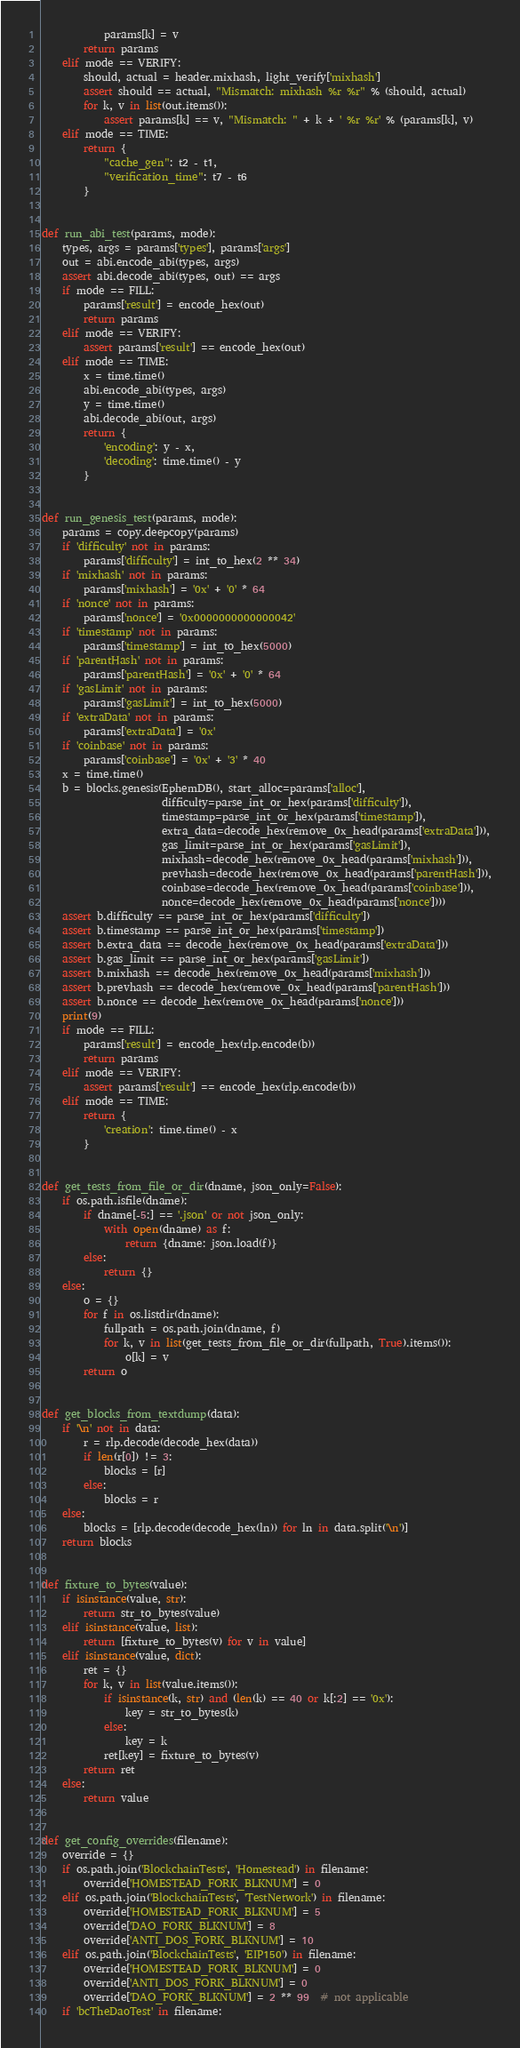Convert code to text. <code><loc_0><loc_0><loc_500><loc_500><_Python_>            params[k] = v
        return params
    elif mode == VERIFY:
        should, actual = header.mixhash, light_verify['mixhash']
        assert should == actual, "Mismatch: mixhash %r %r" % (should, actual)
        for k, v in list(out.items()):
            assert params[k] == v, "Mismatch: " + k + ' %r %r' % (params[k], v)
    elif mode == TIME:
        return {
            "cache_gen": t2 - t1,
            "verification_time": t7 - t6
        }


def run_abi_test(params, mode):
    types, args = params['types'], params['args']
    out = abi.encode_abi(types, args)
    assert abi.decode_abi(types, out) == args
    if mode == FILL:
        params['result'] = encode_hex(out)
        return params
    elif mode == VERIFY:
        assert params['result'] == encode_hex(out)
    elif mode == TIME:
        x = time.time()
        abi.encode_abi(types, args)
        y = time.time()
        abi.decode_abi(out, args)
        return {
            'encoding': y - x,
            'decoding': time.time() - y
        }


def run_genesis_test(params, mode):
    params = copy.deepcopy(params)
    if 'difficulty' not in params:
        params['difficulty'] = int_to_hex(2 ** 34)
    if 'mixhash' not in params:
        params['mixhash'] = '0x' + '0' * 64
    if 'nonce' not in params:
        params['nonce'] = '0x0000000000000042'
    if 'timestamp' not in params:
        params['timestamp'] = int_to_hex(5000)
    if 'parentHash' not in params:
        params['parentHash'] = '0x' + '0' * 64
    if 'gasLimit' not in params:
        params['gasLimit'] = int_to_hex(5000)
    if 'extraData' not in params:
        params['extraData'] = '0x'
    if 'coinbase' not in params:
        params['coinbase'] = '0x' + '3' * 40
    x = time.time()
    b = blocks.genesis(EphemDB(), start_alloc=params['alloc'],
                       difficulty=parse_int_or_hex(params['difficulty']),
                       timestamp=parse_int_or_hex(params['timestamp']),
                       extra_data=decode_hex(remove_0x_head(params['extraData'])),
                       gas_limit=parse_int_or_hex(params['gasLimit']),
                       mixhash=decode_hex(remove_0x_head(params['mixhash'])),
                       prevhash=decode_hex(remove_0x_head(params['parentHash'])),
                       coinbase=decode_hex(remove_0x_head(params['coinbase'])),
                       nonce=decode_hex(remove_0x_head(params['nonce'])))
    assert b.difficulty == parse_int_or_hex(params['difficulty'])
    assert b.timestamp == parse_int_or_hex(params['timestamp'])
    assert b.extra_data == decode_hex(remove_0x_head(params['extraData']))
    assert b.gas_limit == parse_int_or_hex(params['gasLimit'])
    assert b.mixhash == decode_hex(remove_0x_head(params['mixhash']))
    assert b.prevhash == decode_hex(remove_0x_head(params['parentHash']))
    assert b.nonce == decode_hex(remove_0x_head(params['nonce']))
    print(9)
    if mode == FILL:
        params['result'] = encode_hex(rlp.encode(b))
        return params
    elif mode == VERIFY:
        assert params['result'] == encode_hex(rlp.encode(b))
    elif mode == TIME:
        return {
            'creation': time.time() - x
        }


def get_tests_from_file_or_dir(dname, json_only=False):
    if os.path.isfile(dname):
        if dname[-5:] == '.json' or not json_only:
            with open(dname) as f:
                return {dname: json.load(f)}
        else:
            return {}
    else:
        o = {}
        for f in os.listdir(dname):
            fullpath = os.path.join(dname, f)
            for k, v in list(get_tests_from_file_or_dir(fullpath, True).items()):
                o[k] = v
        return o


def get_blocks_from_textdump(data):
    if '\n' not in data:
        r = rlp.decode(decode_hex(data))
        if len(r[0]) != 3:
            blocks = [r]
        else:
            blocks = r
    else:
        blocks = [rlp.decode(decode_hex(ln)) for ln in data.split('\n')]
    return blocks


def fixture_to_bytes(value):
    if isinstance(value, str):
        return str_to_bytes(value)
    elif isinstance(value, list):
        return [fixture_to_bytes(v) for v in value]
    elif isinstance(value, dict):
        ret = {}
        for k, v in list(value.items()):
            if isinstance(k, str) and (len(k) == 40 or k[:2] == '0x'):
                key = str_to_bytes(k)
            else:
                key = k
            ret[key] = fixture_to_bytes(v)
        return ret
    else:
        return value


def get_config_overrides(filename):
    override = {}
    if os.path.join('BlockchainTests', 'Homestead') in filename:
        override['HOMESTEAD_FORK_BLKNUM'] = 0
    elif os.path.join('BlockchainTests', 'TestNetwork') in filename:
        override['HOMESTEAD_FORK_BLKNUM'] = 5
        override['DAO_FORK_BLKNUM'] = 8
        override['ANTI_DOS_FORK_BLKNUM'] = 10
    elif os.path.join('BlockchainTests', 'EIP150') in filename:
        override['HOMESTEAD_FORK_BLKNUM'] = 0
        override['ANTI_DOS_FORK_BLKNUM'] = 0
        override['DAO_FORK_BLKNUM'] = 2 ** 99  # not applicable
    if 'bcTheDaoTest' in filename:</code> 